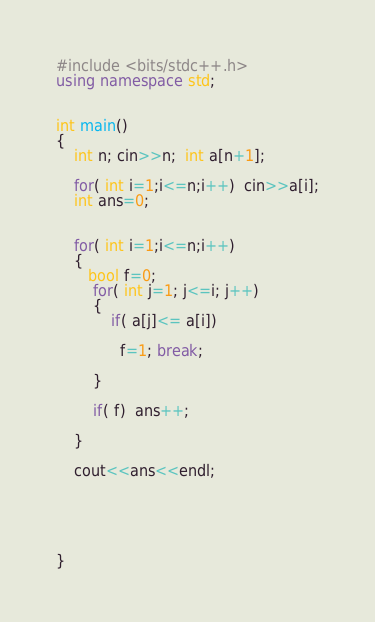Convert code to text. <code><loc_0><loc_0><loc_500><loc_500><_C++_>
#include <bits/stdc++.h> 
using namespace std; 


int main()
{
	int n; cin>>n;  int a[n+1];
	
	for( int i=1;i<=n;i++)  cin>>a[i];
    int ans=0;
    
    
    for( int i=1;i<=n;i++)
    {  
       bool f=0;
    	for( int j=1; j<=i; j++)
    	{
    		if( a[j]<= a[i]) 
		
			  f=1; break;
		
		}
		
		if( f)  ans++;
		
	}
	
	cout<<ans<<endl;

	
	

	
}</code> 